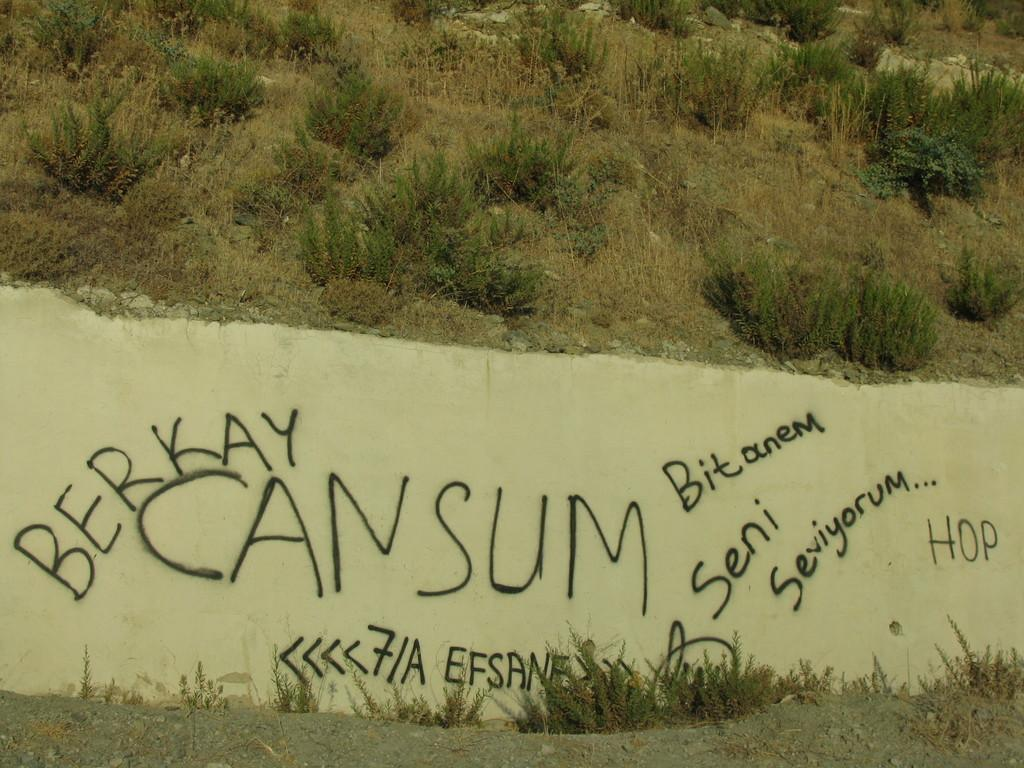What is present in the image that serves as a background or barrier? There is a wall in the image. What is on the wall in the image? Text has been written on the wall. What type of vegetation can be seen at the top of the image? There are many plants at the top of the image. What type of tail can be seen on the plants at the top of the image? There are no tails present on the plants in the image; they are simply plants. 